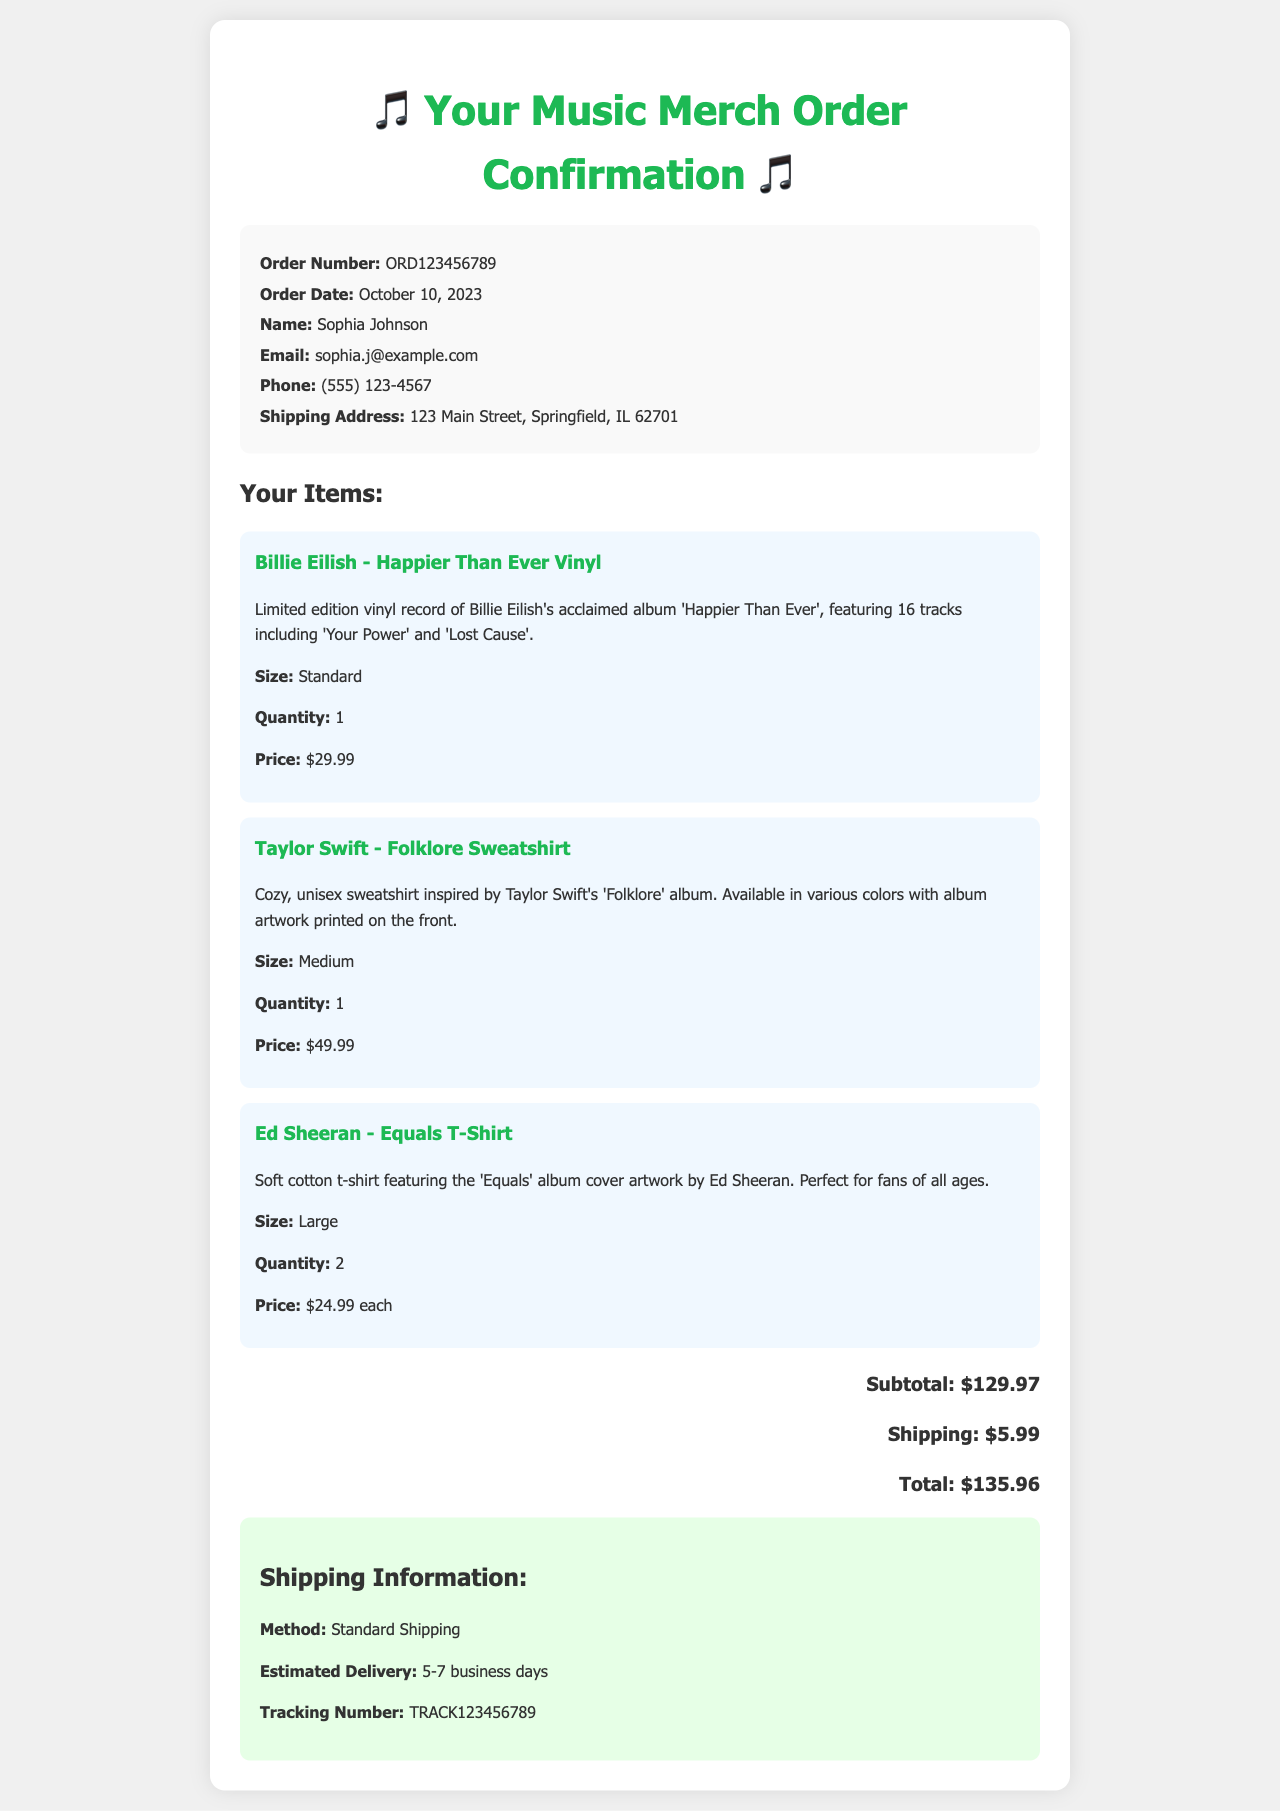what is the order number? The order number is listed at the top of the order info section, which identifies this specific order.
Answer: ORD123456789 who is the order placed by? The name of the individual who placed the order is provided in the order info section.
Answer: Sophia Johnson when was the order placed? The order date is mentioned in the order info section, indicating when the order was made.
Answer: October 10, 2023 what is the total cost of the order? The total cost represents the sum of the subtotal and shipping cost provided at the bottom of the order.
Answer: $135.96 how many items were ordered from Ed Sheeran? The item count for Ed Sheeran's merchandise is stated in the items section, indicating the specific quantity purchased.
Answer: 2 what is the estimated delivery time? The estimated delivery time is mentioned in the shipping information section, providing an idea of when the order will arrive.
Answer: 5-7 business days what color is the Taylor Swift sweatshirt? The document states that the sweatshirt is available in various colors but does not specify a single color.
Answer: Various colors what shipping method is used for this order? The shipping method is detailed in the shipping information subsection, which explains how the order will be delivered.
Answer: Standard Shipping where is the shipping address? The shipping address is explicitly stated in the order info section, showing where the items are to be sent.
Answer: 123 Main Street, Springfield, IL 62701 